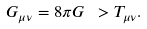<formula> <loc_0><loc_0><loc_500><loc_500>G _ { \mu \nu } = 8 \pi G \ > T _ { \mu \nu } .</formula> 